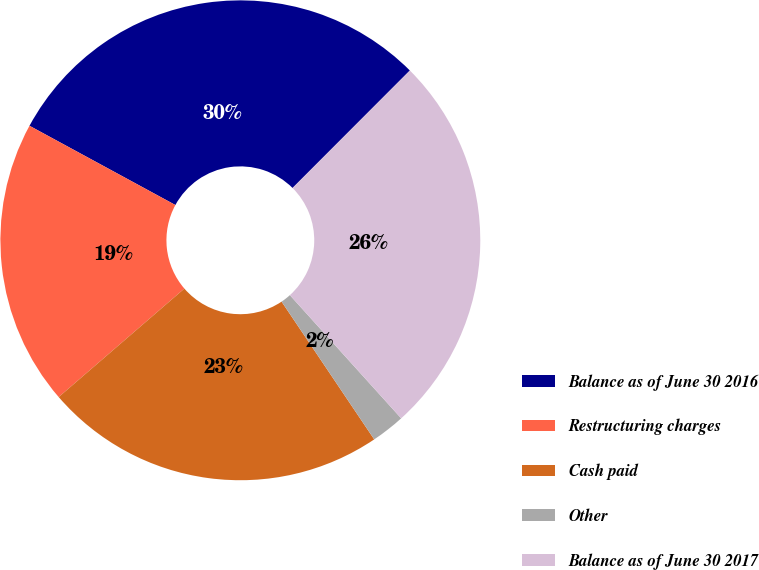Convert chart. <chart><loc_0><loc_0><loc_500><loc_500><pie_chart><fcel>Balance as of June 30 2016<fcel>Restructuring charges<fcel>Cash paid<fcel>Other<fcel>Balance as of June 30 2017<nl><fcel>29.57%<fcel>19.25%<fcel>23.09%<fcel>2.27%<fcel>25.82%<nl></chart> 